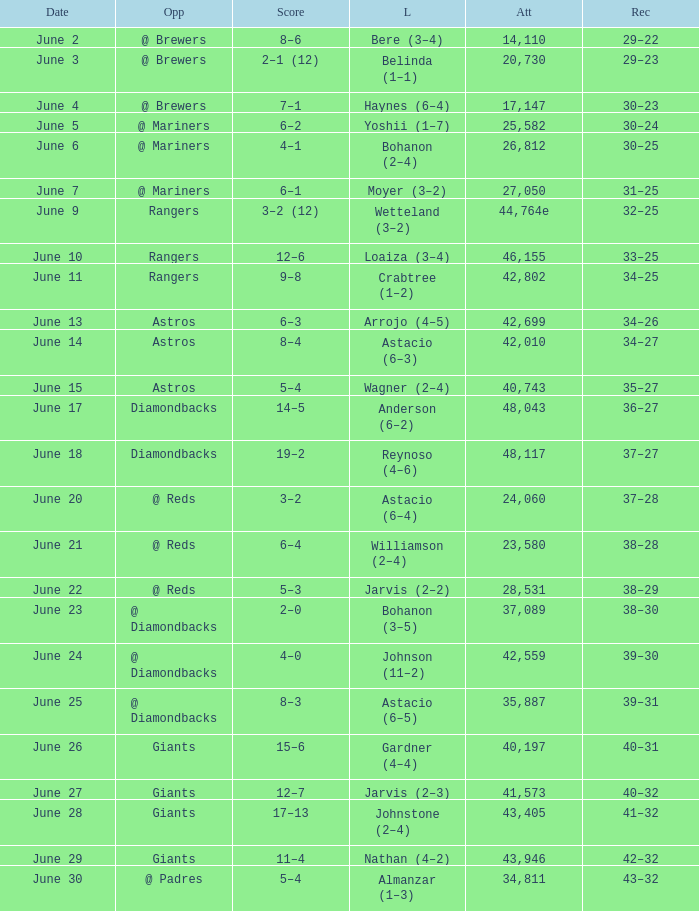Who's the opponent for June 13? Astros. 